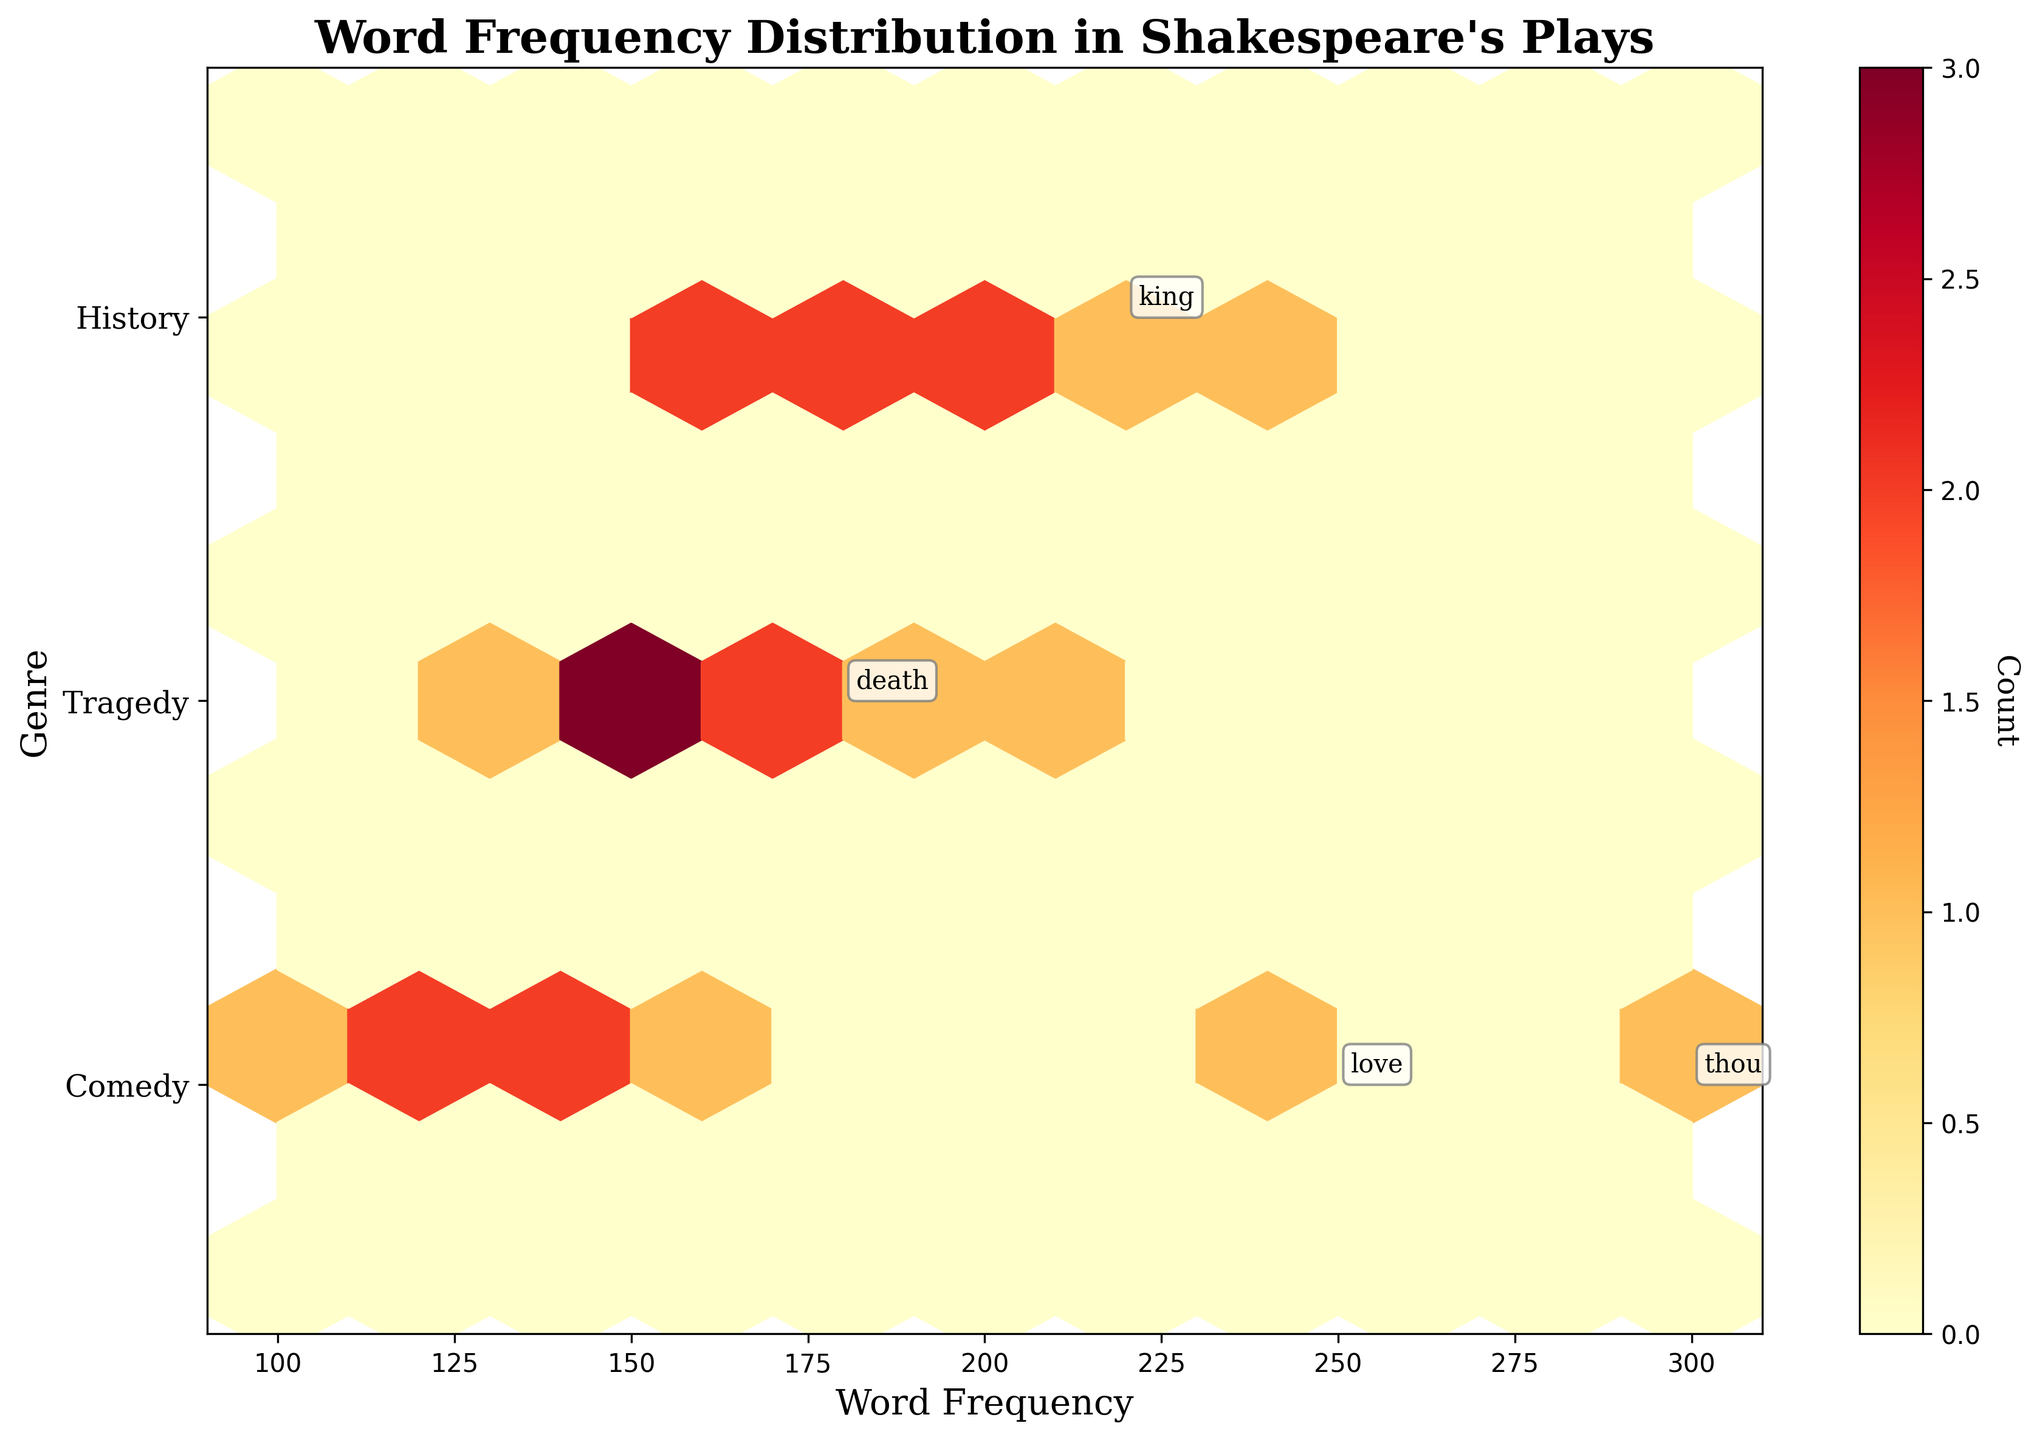What is the title of the hexbin plot? The title is displayed at the top of the plot in bold font and reads: "Word Frequency Distribution in Shakespeare's Plays".
Answer: Word Frequency Distribution in Shakespeare's Plays How many genres are represented on the y-axis? The y-axis has three ticks labeled "Comedy", "Tragedy", and "History", indicating three different genres.
Answer: Three Which word has the highest frequency in the Comedy genre? The annotation for the "Comedy" genre shows the word "thou" with the highest frequency of 300.
Answer: thou What does the colorbar represent? The colorbar on the right side of the plot has a label "Count" and shows the color gradient, representing the count of words within each hexbin.
Answer: Count Which genre has a word with a frequency of 200, and what is the word? The word with a frequency of 200 is annotated, and it falls under the "History" genre, labeled as "battle".
Answer: History, battle How many words have frequencies greater than 240? The annotated words with frequencies greater than 240 are "love", "thou", and "war", totaling three words.
Answer: Three What is the range of word frequencies shown on the x-axis? The x-axis ranges are displayed from 100 to 300, which is the span of word frequencies in the figure.
Answer: 100 to 300 Which word from the "Tragedy" genre appears near the highest frequency? The word "death" is annotated and shows a frequency of 180. Other words in "Tragedy" have lower frequencies based on their position.
Answer: death Comparing the words with the highest frequency in "Comedy" and "History", which one has a higher frequency? The highest frequency word in "Comedy" is "thou" with 300, and in "History" it is "war" with 240. Since 300 is greater than 240, "thou" has a higher frequency.
Answer: thou What does the density of the hexbin in the middle of the plot indicate? Hexbins with denser (darker) shades of color within the plot represent a higher concentration of word frequencies around those values.
Answer: Higher concentration of frequencies 